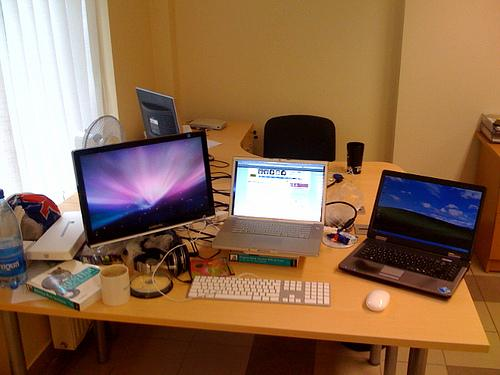What is the white rounded object on the right? mouse 